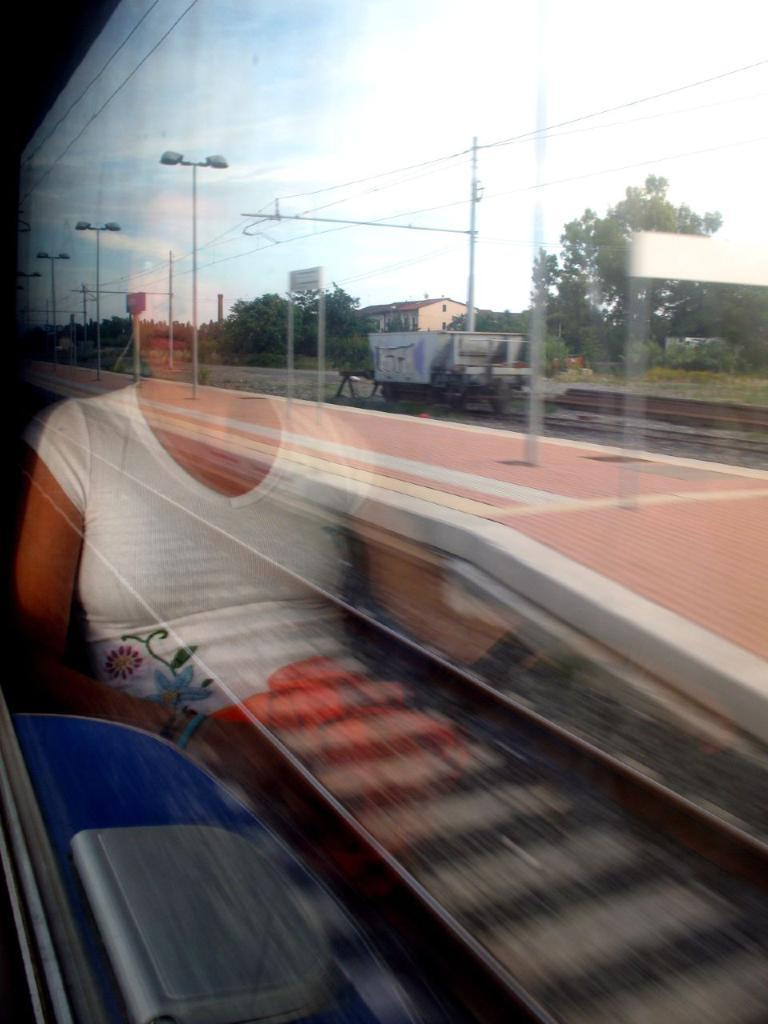What object is present in the image that can hold a liquid? There is a glass in the image. What is depicted on the glass? The glass has a person on it. What can be seen in the background of the image? There is a railway track, a platform, trees, and a building in the background of the image. How does the glass compare to a circle in the image? The glass is not a circle; it is a glass with a person depicted on it. Where can you buy the glass in the image? There is no information about where to buy the glass in the image. 